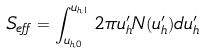Convert formula to latex. <formula><loc_0><loc_0><loc_500><loc_500>S _ { e f f } = \int _ { u _ { h , 0 } } ^ { u _ { h , 1 } } 2 \pi u _ { h } ^ { \prime } N ( u _ { h } ^ { \prime } ) d u _ { h } ^ { \prime }</formula> 